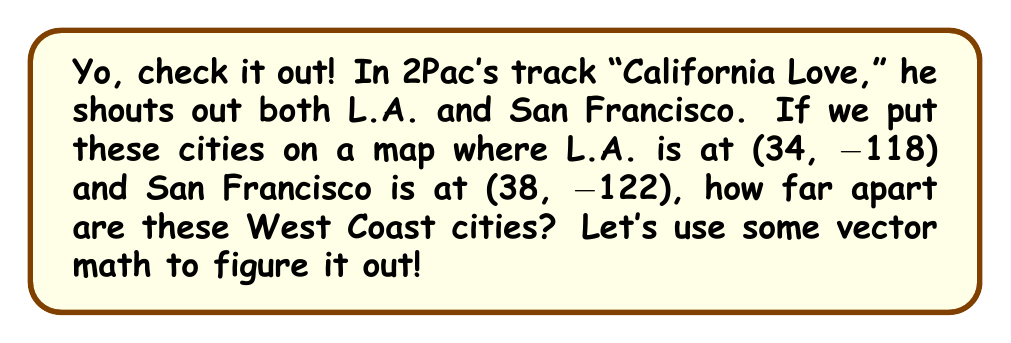Teach me how to tackle this problem. Alright, let's break this down step by step:

1) First, we need to understand what these numbers mean. They're latitude and longitude coordinates. We can treat them like points on a 2D plane for our calculation.

2) We can think of each city as a vector from the origin (0, 0) to its location:
   L.A. vector: $\vec{v_1} = (34, -118)$
   San Francisco vector: $\vec{v_2} = (38, -122)$

3) To find the distance between these cities, we need to find the vector that goes from L.A. to San Francisco. We can do this by subtracting the L.A. vector from the San Francisco vector:

   $\vec{v} = \vec{v_2} - \vec{v_1} = (38, -122) - (34, -118) = (4, -4)$

4) Now, this vector $\vec{v}$ represents the direction and distance from L.A. to San Francisco. To find the actual distance, we need to find the length (magnitude) of this vector.

5) We can find the magnitude using the Pythagorean theorem:

   $\text{Distance} = \sqrt{x^2 + y^2}$ where $x$ and $y$ are the components of $\vec{v}$

6) Plugging in our values:

   $\text{Distance} = \sqrt{4^2 + (-4)^2} = \sqrt{16 + 16} = \sqrt{32} = 4\sqrt{2}$

7) This gives us the distance in degrees. To convert to miles (since we're talking about U.S. cities), we need to multiply by the number of miles per degree at this latitude, which is approximately 69.

   $\text{Distance in miles} \approx 4\sqrt{2} * 69 \approx 390$ miles

So, that's how far apart L.A. and San Francisco are, using some vector math!
Answer: The distance between Los Angeles and San Francisco is approximately 390 miles. 